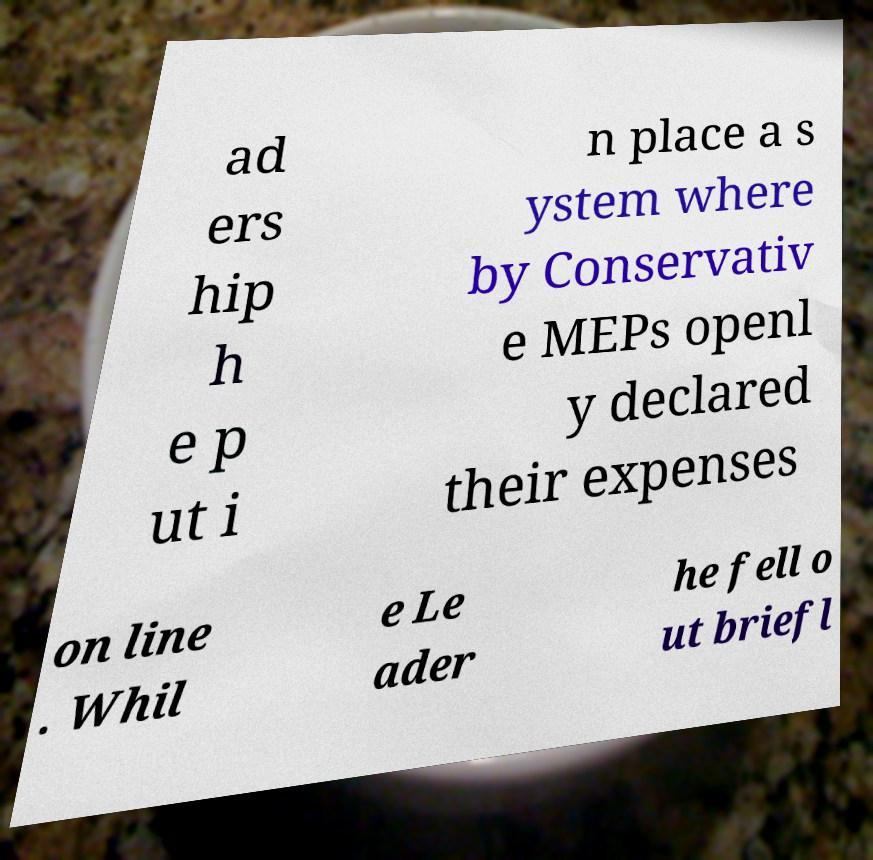Could you assist in decoding the text presented in this image and type it out clearly? ad ers hip h e p ut i n place a s ystem where by Conservativ e MEPs openl y declared their expenses on line . Whil e Le ader he fell o ut briefl 